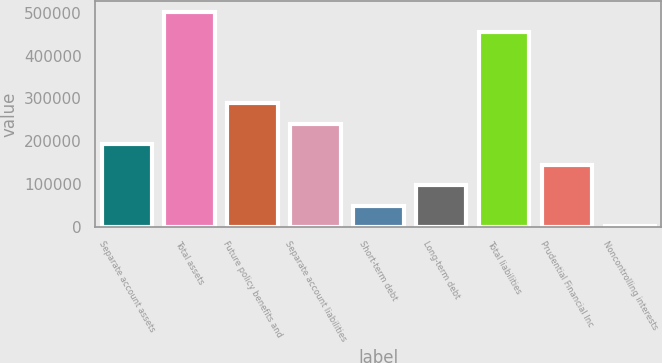<chart> <loc_0><loc_0><loc_500><loc_500><bar_chart><fcel>Separate account assets<fcel>Total assets<fcel>Future policy benefits and<fcel>Separate account liabilities<fcel>Short-term debt<fcel>Long-term debt<fcel>Total liabilities<fcel>Prudential Financial Inc<fcel>Noncontrolling interests<nl><fcel>192402<fcel>502441<fcel>288335<fcel>240368<fcel>48500.9<fcel>96467.8<fcel>454474<fcel>144435<fcel>534<nl></chart> 